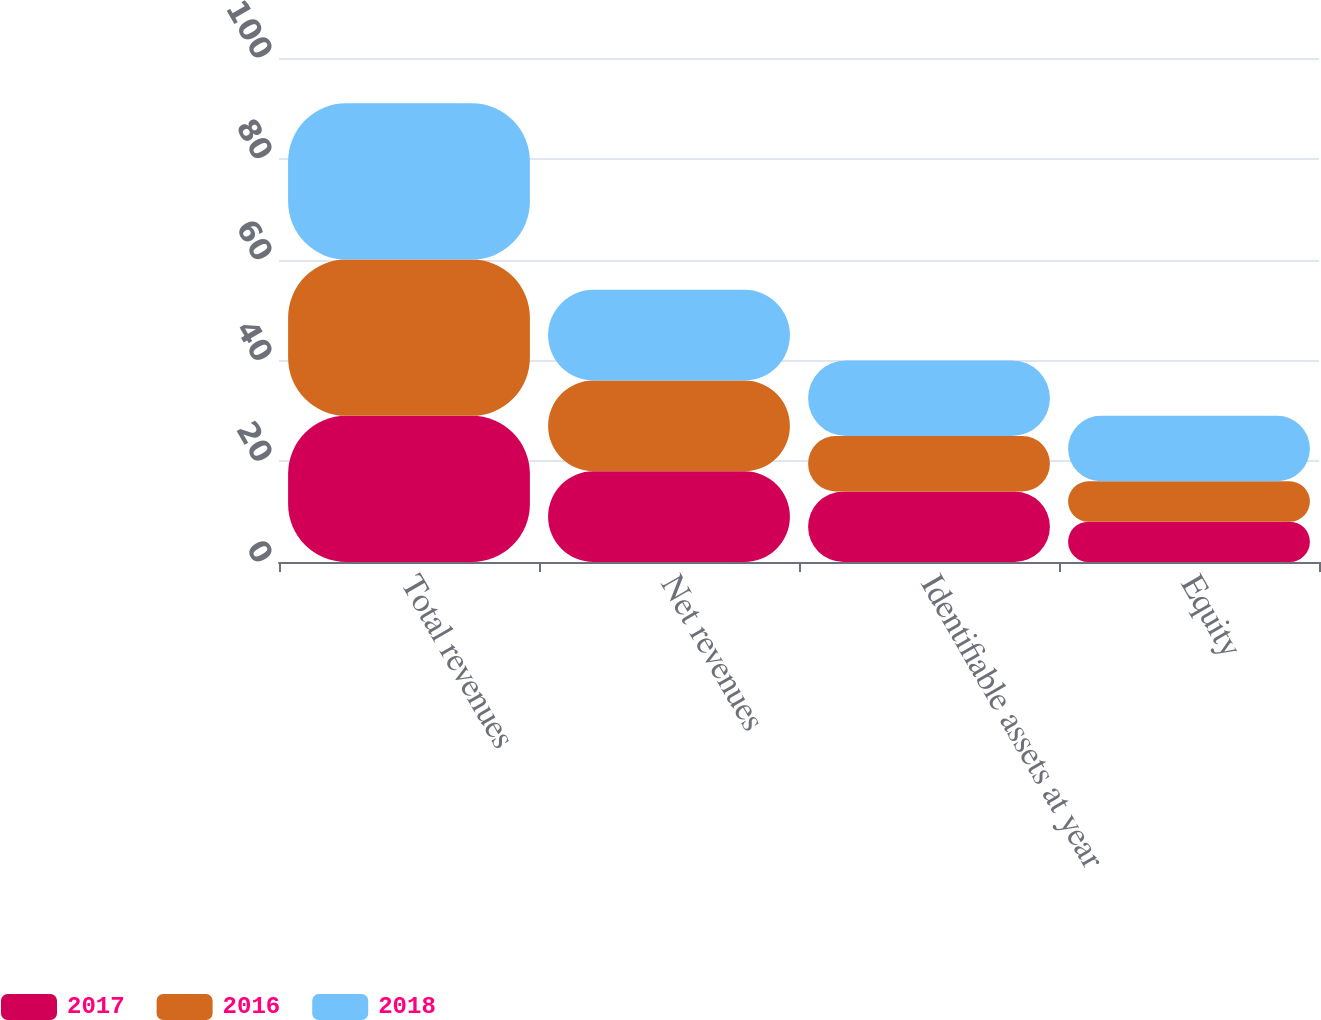Convert chart. <chart><loc_0><loc_0><loc_500><loc_500><stacked_bar_chart><ecel><fcel>Total revenues<fcel>Net revenues<fcel>Identifiable assets at year<fcel>Equity<nl><fcel>2017<fcel>29<fcel>18<fcel>14<fcel>8<nl><fcel>2016<fcel>31<fcel>18<fcel>11<fcel>8<nl><fcel>2018<fcel>31<fcel>18<fcel>15<fcel>13<nl></chart> 